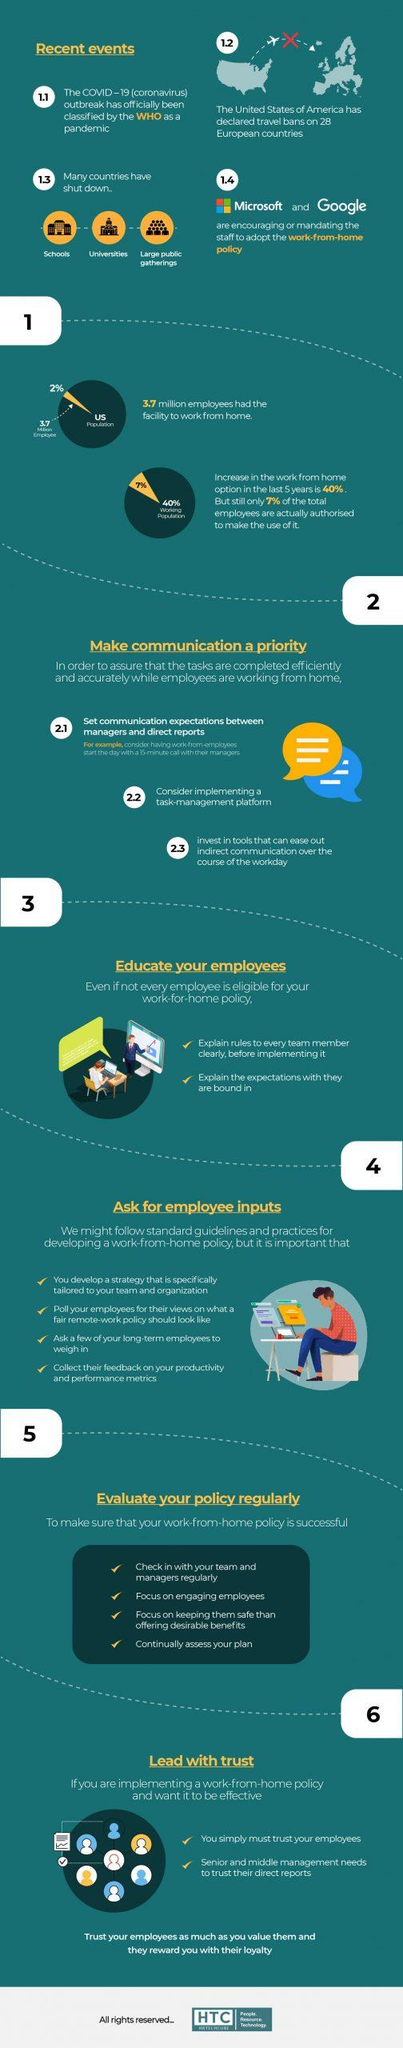Identify some key points in this picture. There are 4 points under the heading 'Ask for employee inputs'. Under the heading 'Educate Your Employees,' there are currently two points. It is reported that two companies are currently implementing a work-from-home policy that encourages remote work. 